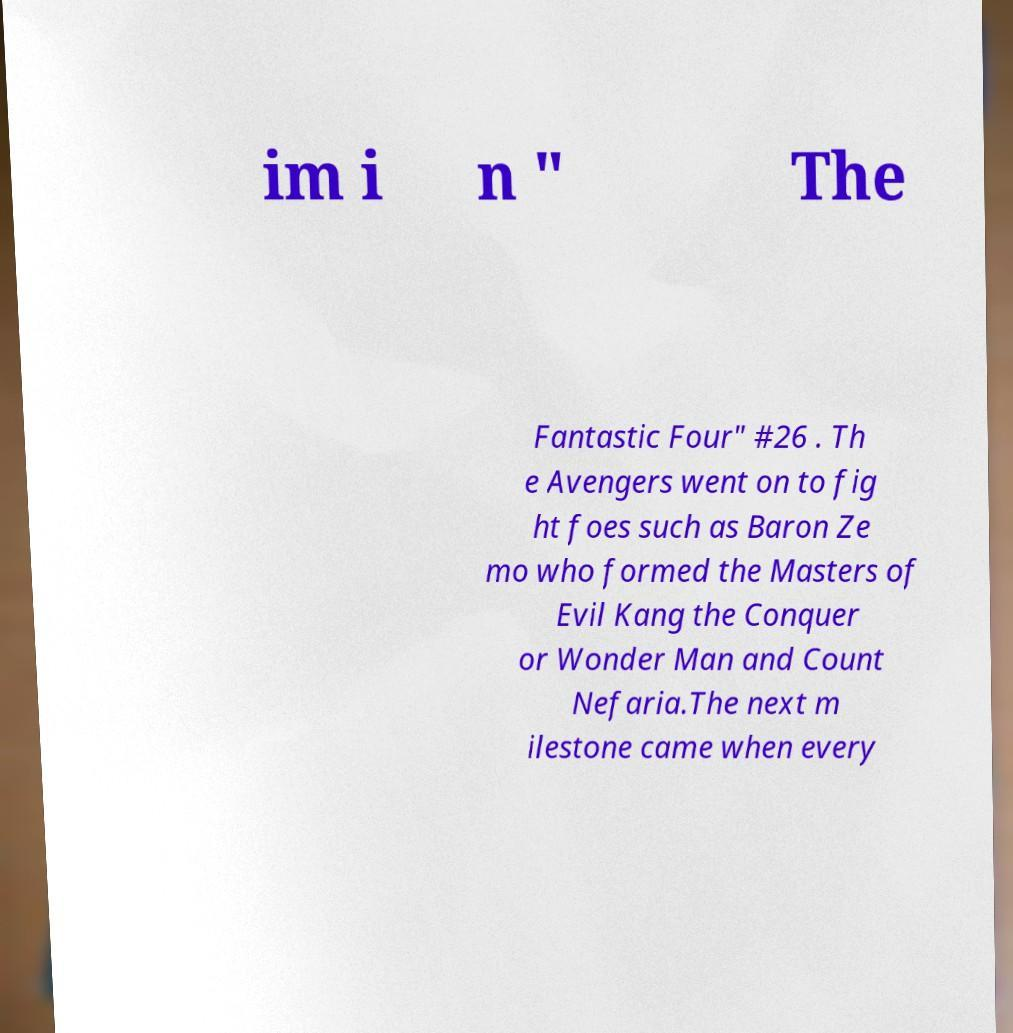There's text embedded in this image that I need extracted. Can you transcribe it verbatim? im i n " The Fantastic Four" #26 . Th e Avengers went on to fig ht foes such as Baron Ze mo who formed the Masters of Evil Kang the Conquer or Wonder Man and Count Nefaria.The next m ilestone came when every 